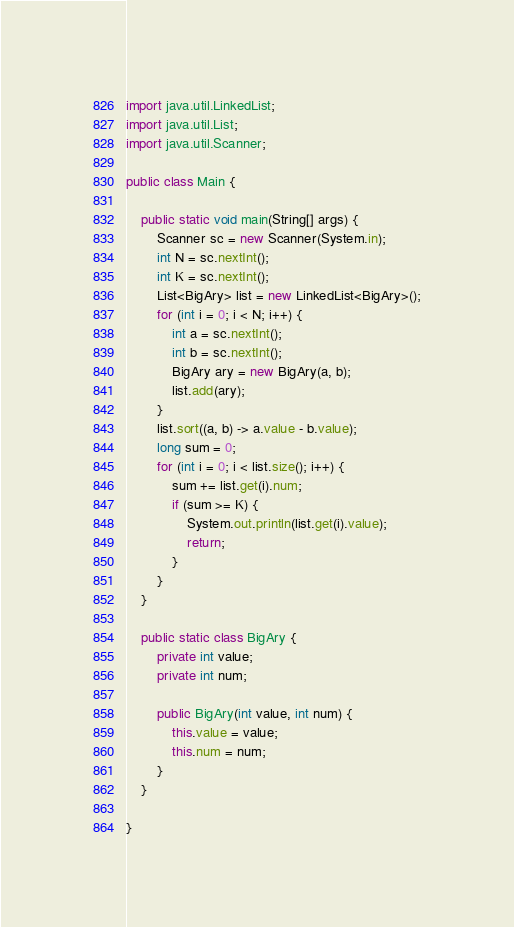Convert code to text. <code><loc_0><loc_0><loc_500><loc_500><_Java_>import java.util.LinkedList;
import java.util.List;
import java.util.Scanner;

public class Main {

	public static void main(String[] args) {
		Scanner sc = new Scanner(System.in);
		int N = sc.nextInt();
		int K = sc.nextInt();
		List<BigAry> list = new LinkedList<BigAry>();
		for (int i = 0; i < N; i++) {
			int a = sc.nextInt();
			int b = sc.nextInt();
			BigAry ary = new BigAry(a, b);
			list.add(ary);
		}
		list.sort((a, b) -> a.value - b.value);
		long sum = 0;
		for (int i = 0; i < list.size(); i++) {
			sum += list.get(i).num;
			if (sum >= K) {
				System.out.println(list.get(i).value);
				return;
			}
		}
	}

	public static class BigAry {
		private int value;
		private int num;

		public BigAry(int value, int num) {
			this.value = value;
			this.num = num;
		}
	}

}</code> 